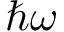Convert formula to latex. <formula><loc_0><loc_0><loc_500><loc_500>\hbar { \omega }</formula> 